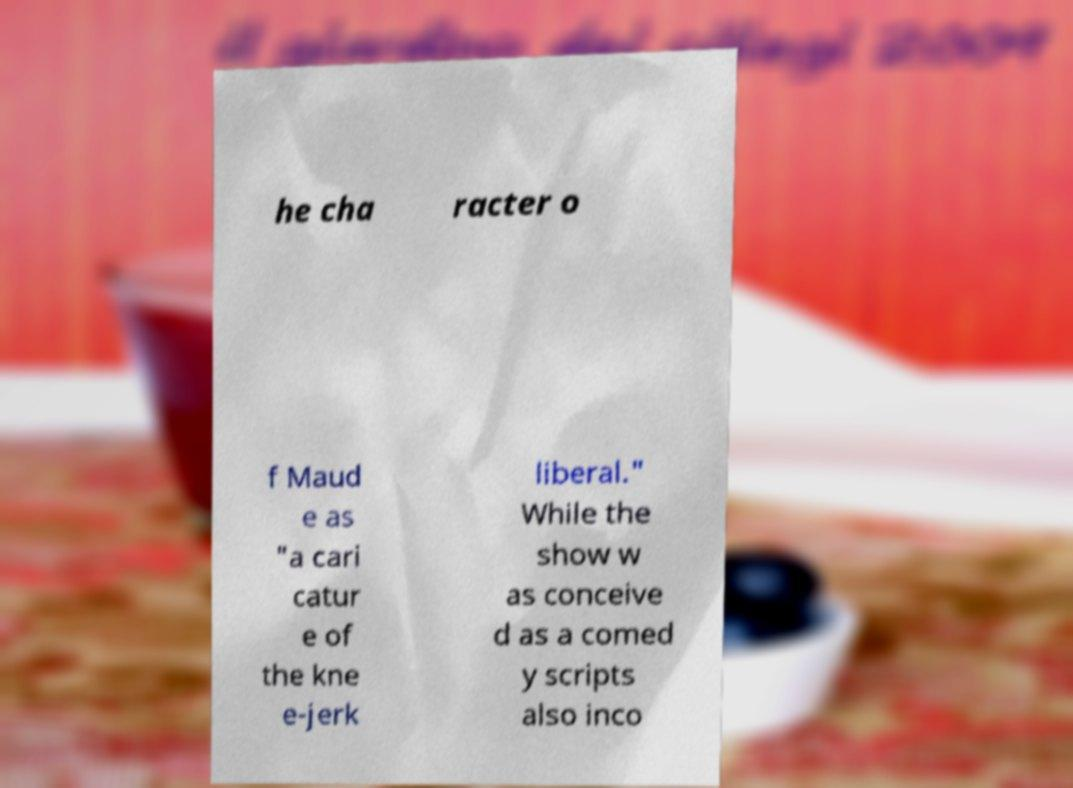Can you accurately transcribe the text from the provided image for me? he cha racter o f Maud e as "a cari catur e of the kne e-jerk liberal." While the show w as conceive d as a comed y scripts also inco 